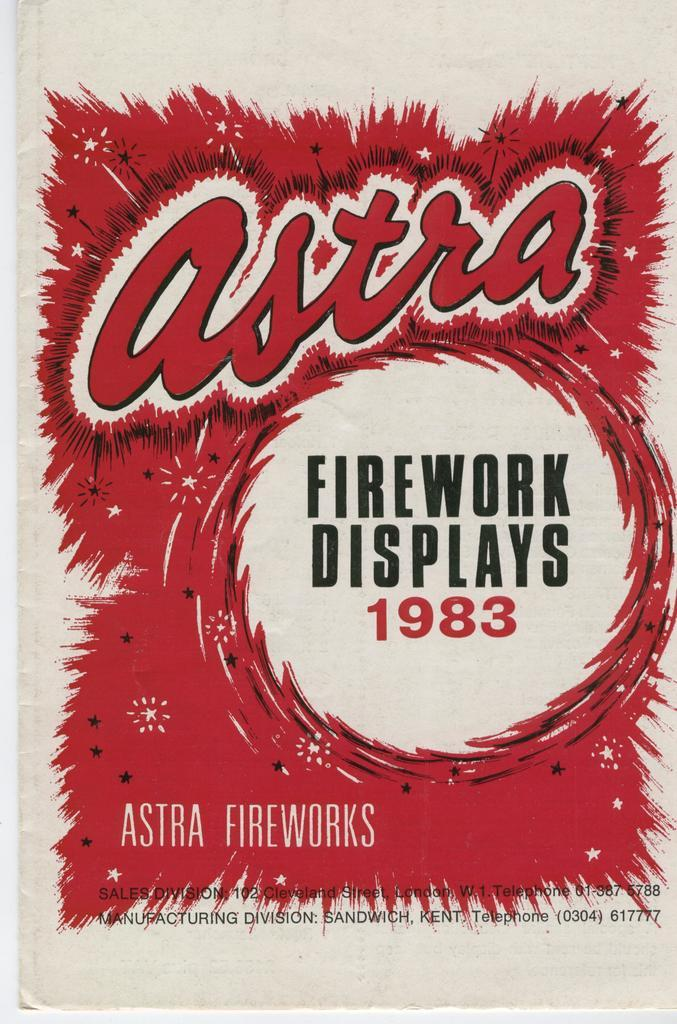<image>
Provide a brief description of the given image. An image advertising Astra Fireworks that was printed in 1983. 